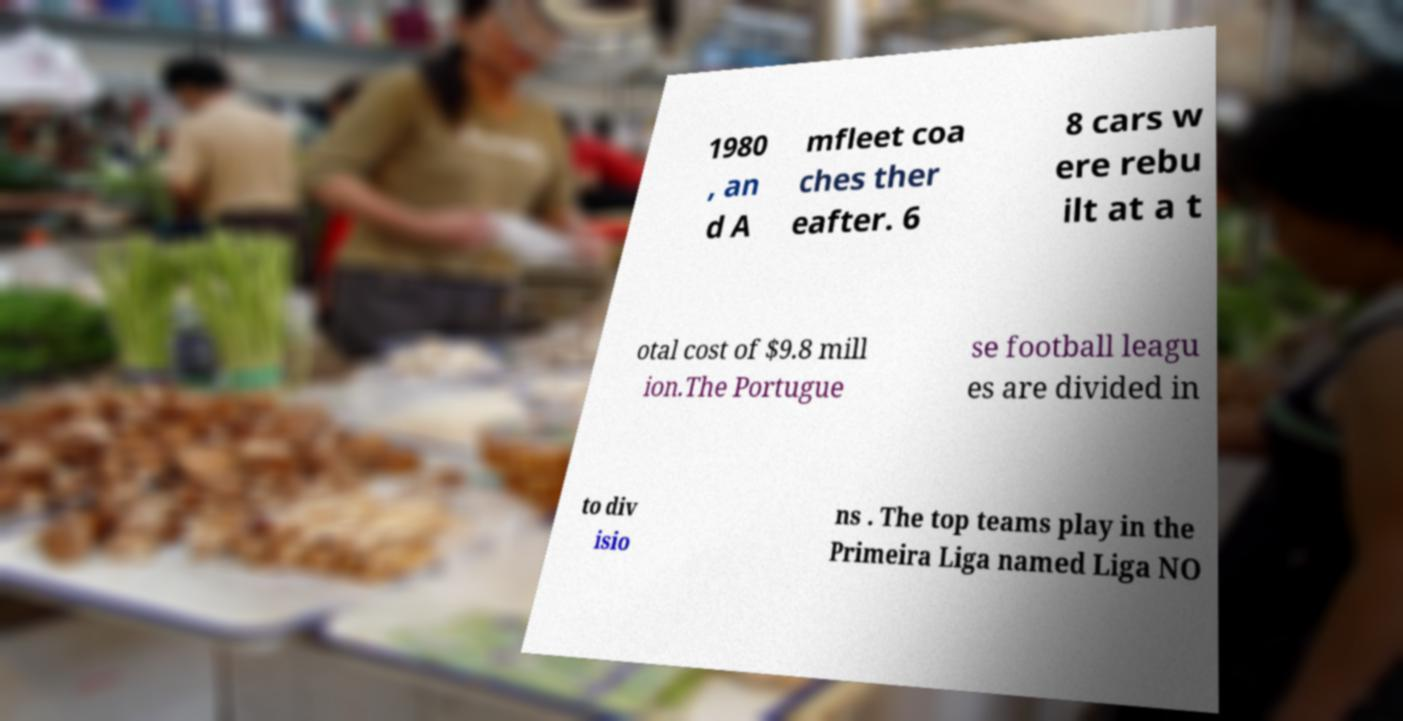What messages or text are displayed in this image? I need them in a readable, typed format. 1980 , an d A mfleet coa ches ther eafter. 6 8 cars w ere rebu ilt at a t otal cost of $9.8 mill ion.The Portugue se football leagu es are divided in to div isio ns . The top teams play in the Primeira Liga named Liga NO 